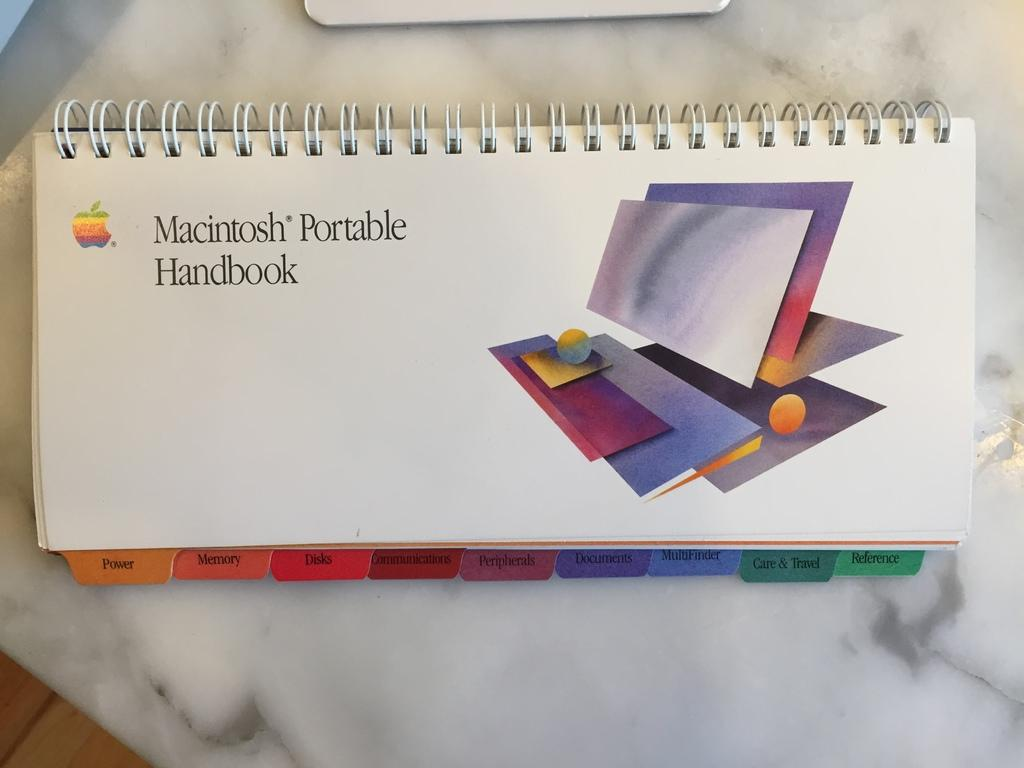<image>
Give a short and clear explanation of the subsequent image. a spiral book for macintosh portable handbook with colorful tabs at the bottom 